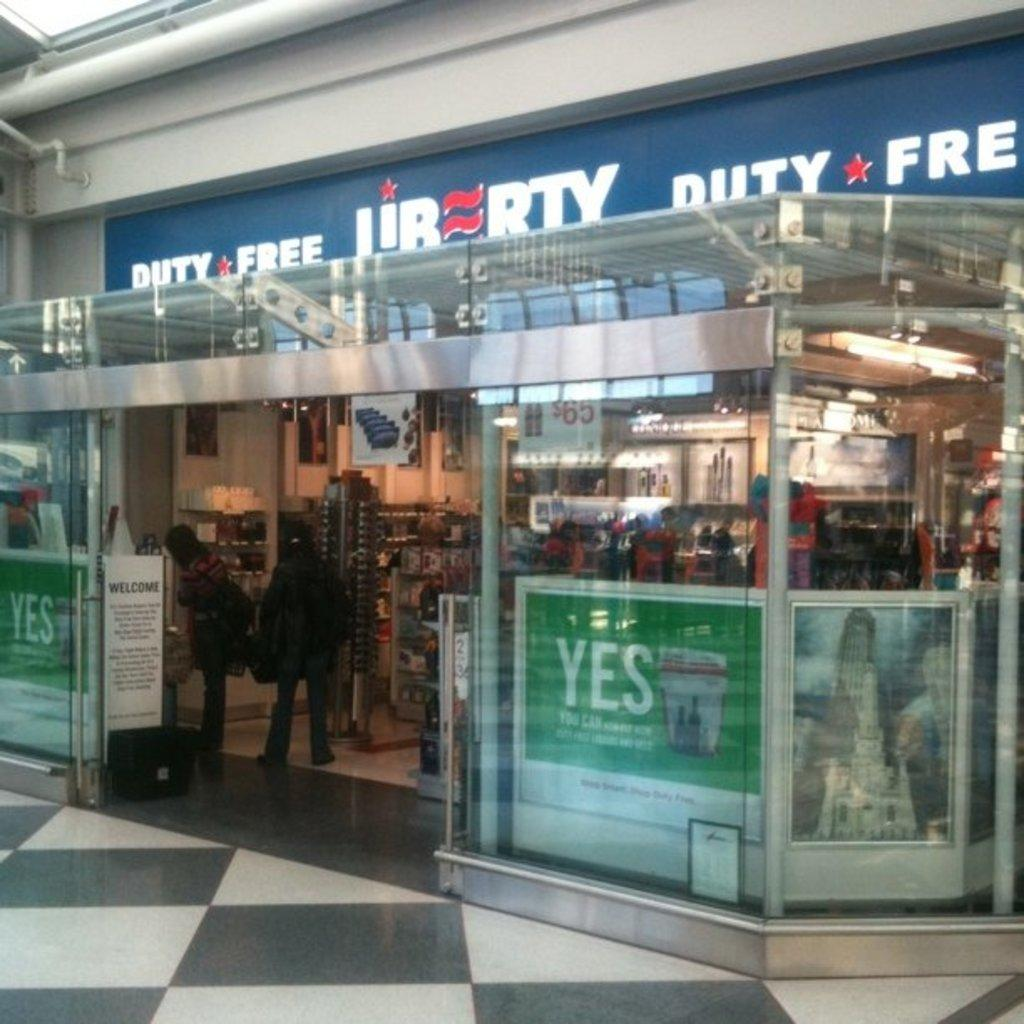<image>
Share a concise interpretation of the image provided. The blue sign says Duty Free on the top of it 